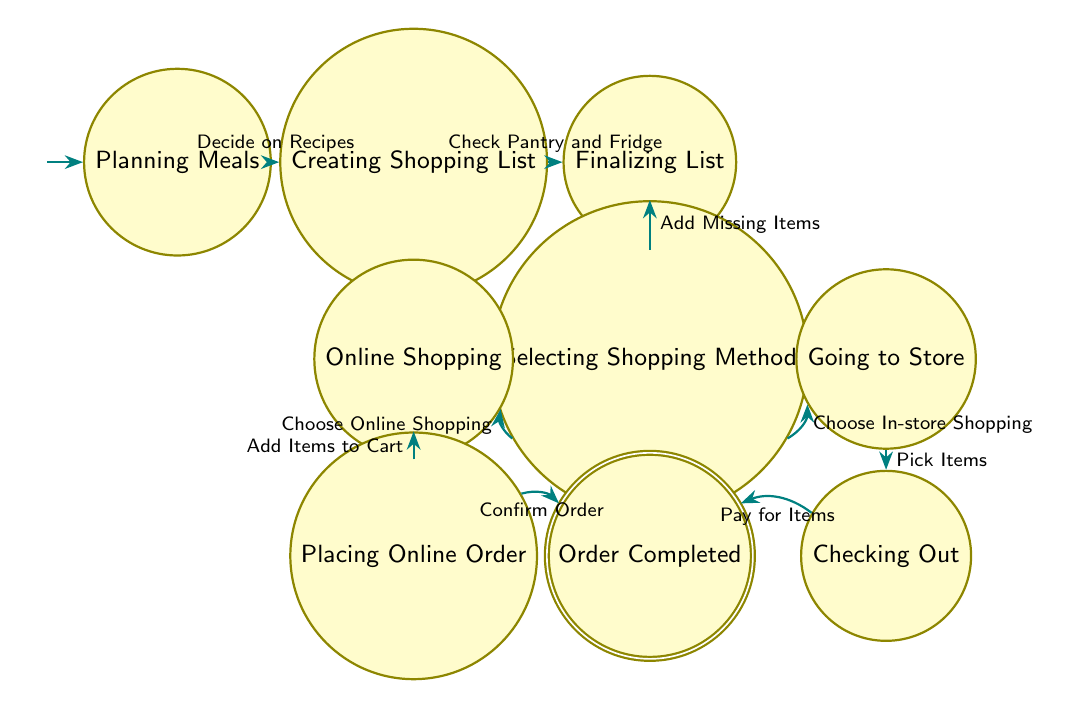What is the first state in the workflow? The first state is labeled "Planning Meals," which is the starting point of the workflow in the diagram.
Answer: Planning Meals How many states are present in the diagram? By counting the individual labeled nodes in the diagram, there are a total of eight distinct states.
Answer: Eight What action leads to the state "Creating Shopping List"? The state "Creating Shopping List" is reached by performing the action "Decide on Recipes" from the previous state "Planning Meals."
Answer: Decide on Recipes Which state follows "Finalizing List"? The state that follows "Finalizing List" is "Selecting Shopping Method," as indicated by the transition from one to the other after "Add Missing Items" action is completed.
Answer: Selecting Shopping Method If "Choose In-store Shopping" is selected, what is the next state? If the action "Choose In-store Shopping" is taken, the diagram shows that the next state will be "Going to Store."
Answer: Going to Store What are the two methods of shopping illustrated in the diagram? The two methods of shopping indicated are "Online Shopping" and "In-store Shopping," represented by the branches from the "Selecting Shopping Method" state.
Answer: Online Shopping, In-store Shopping What action is required to complete the online shopping process? To finalize the online shopping process, the action "Confirm Order" must be taken after adding items to the cart.
Answer: Confirm Order What is the final state in the workflow? The final state, which indicates that the entire shopping workflow has been completed, is labeled "Order Completed."
Answer: Order Completed After "Checking Out," what is the next state? After the "Checking Out" state is completed by the action "Pay for Items," the next state is "Order Completed," which signifies the end of the workflow.
Answer: Order Completed 